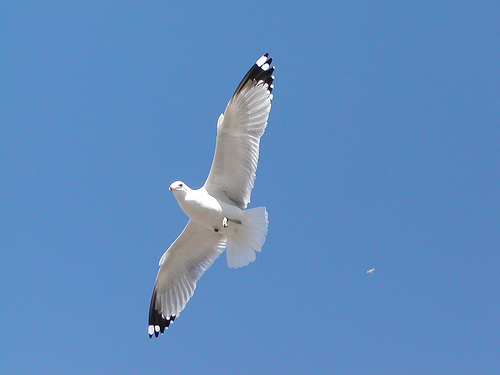<image>
Is the fish in the ocean? No. The fish is not contained within the ocean. These objects have a different spatial relationship. Where is the bird in relation to the bird? Is it next to the bird? No. The bird is not positioned next to the bird. They are located in different areas of the scene. 